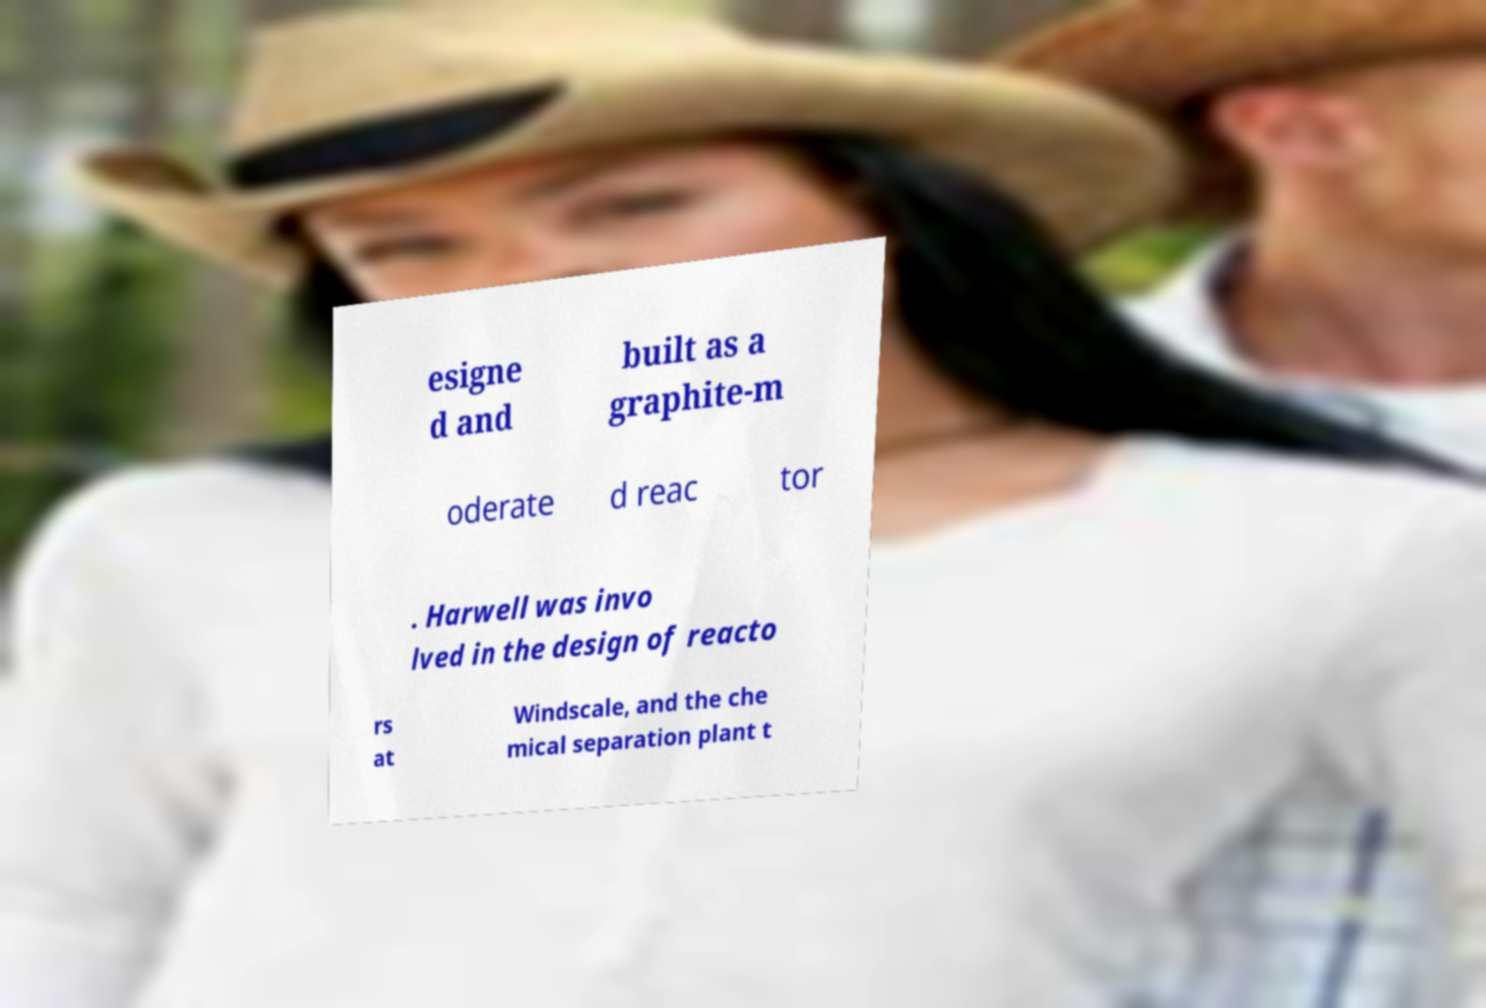Could you assist in decoding the text presented in this image and type it out clearly? esigne d and built as a graphite-m oderate d reac tor . Harwell was invo lved in the design of reacto rs at Windscale, and the che mical separation plant t 